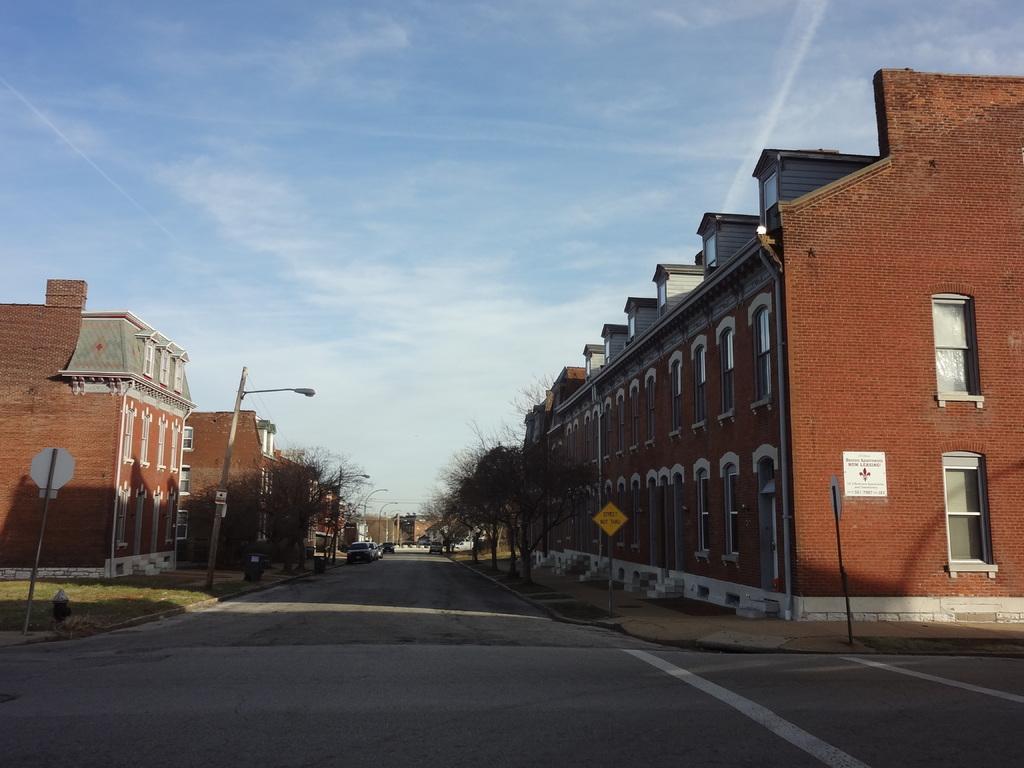Can you describe this image briefly? In this image we can see buildings, motor vehicles on the road, sign boards, street poles, street lights, trees and sky with clouds. 